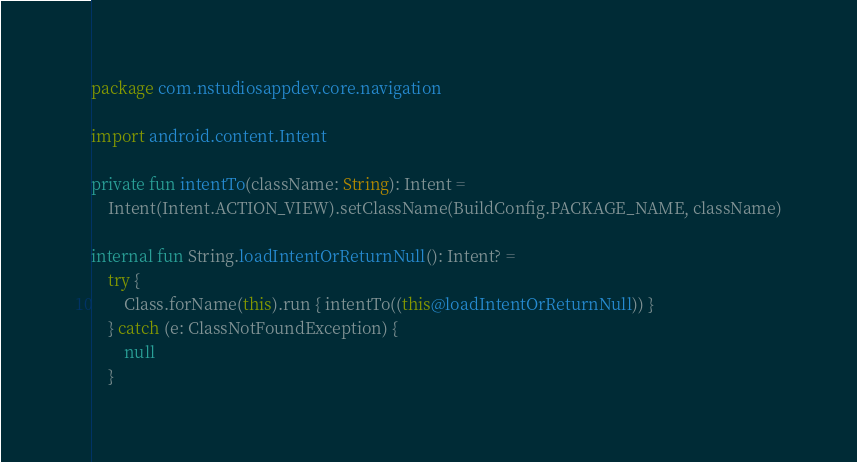Convert code to text. <code><loc_0><loc_0><loc_500><loc_500><_Kotlin_>package com.nstudiosappdev.core.navigation

import android.content.Intent

private fun intentTo(className: String): Intent =
    Intent(Intent.ACTION_VIEW).setClassName(BuildConfig.PACKAGE_NAME, className)

internal fun String.loadIntentOrReturnNull(): Intent? =
    try {
        Class.forName(this).run { intentTo((this@loadIntentOrReturnNull)) }
    } catch (e: ClassNotFoundException) {
        null
    }
</code> 